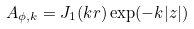<formula> <loc_0><loc_0><loc_500><loc_500>A _ { \phi , k } = J _ { 1 } ( k r ) \exp ( - k | z | )</formula> 